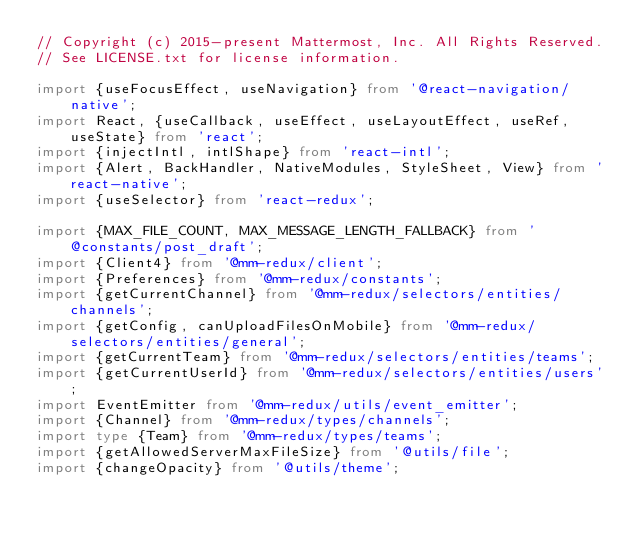<code> <loc_0><loc_0><loc_500><loc_500><_TypeScript_>// Copyright (c) 2015-present Mattermost, Inc. All Rights Reserved.
// See LICENSE.txt for license information.

import {useFocusEffect, useNavigation} from '@react-navigation/native';
import React, {useCallback, useEffect, useLayoutEffect, useRef, useState} from 'react';
import {injectIntl, intlShape} from 'react-intl';
import {Alert, BackHandler, NativeModules, StyleSheet, View} from 'react-native';
import {useSelector} from 'react-redux';

import {MAX_FILE_COUNT, MAX_MESSAGE_LENGTH_FALLBACK} from '@constants/post_draft';
import {Client4} from '@mm-redux/client';
import {Preferences} from '@mm-redux/constants';
import {getCurrentChannel} from '@mm-redux/selectors/entities/channels';
import {getConfig, canUploadFilesOnMobile} from '@mm-redux/selectors/entities/general';
import {getCurrentTeam} from '@mm-redux/selectors/entities/teams';
import {getCurrentUserId} from '@mm-redux/selectors/entities/users';
import EventEmitter from '@mm-redux/utils/event_emitter';
import {Channel} from '@mm-redux/types/channels';
import type {Team} from '@mm-redux/types/teams';
import {getAllowedServerMaxFileSize} from '@utils/file';
import {changeOpacity} from '@utils/theme';
</code> 